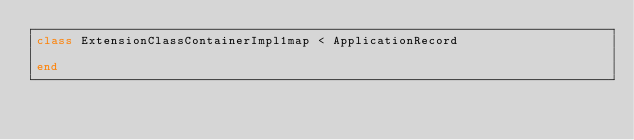<code> <loc_0><loc_0><loc_500><loc_500><_Ruby_>class ExtensionClassContainerImpl1map < ApplicationRecord

end
</code> 